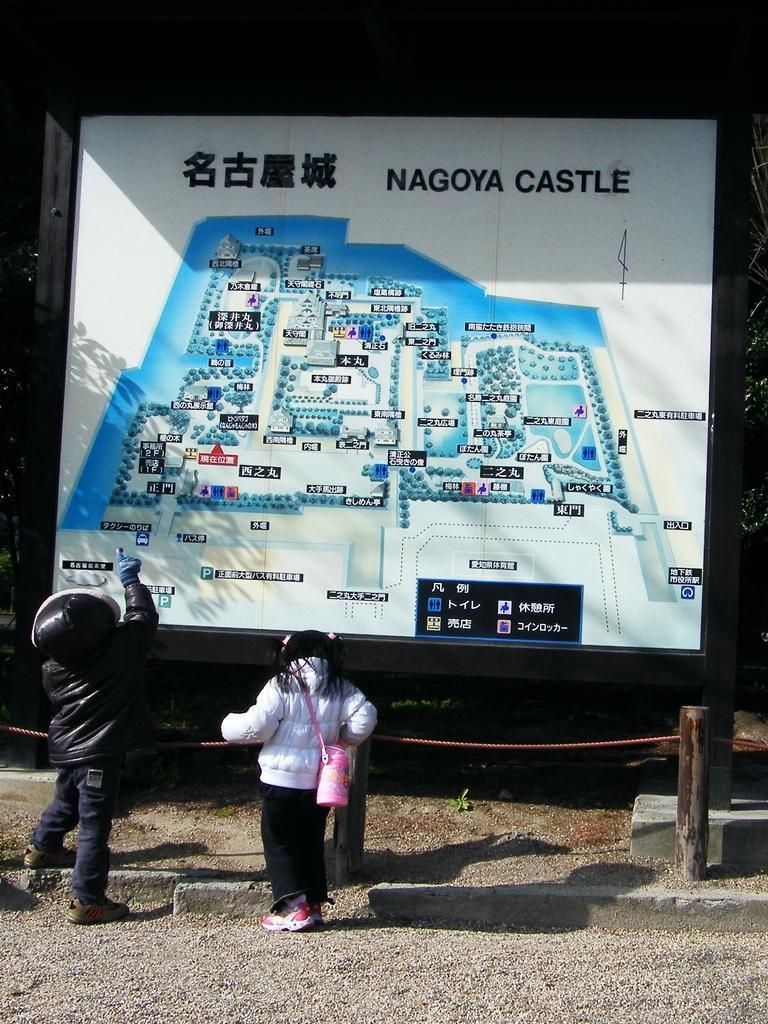Describe this image in one or two sentences. In this image we can see a man and a woman standing near a large board. We can also see a rope tied to a pole. 